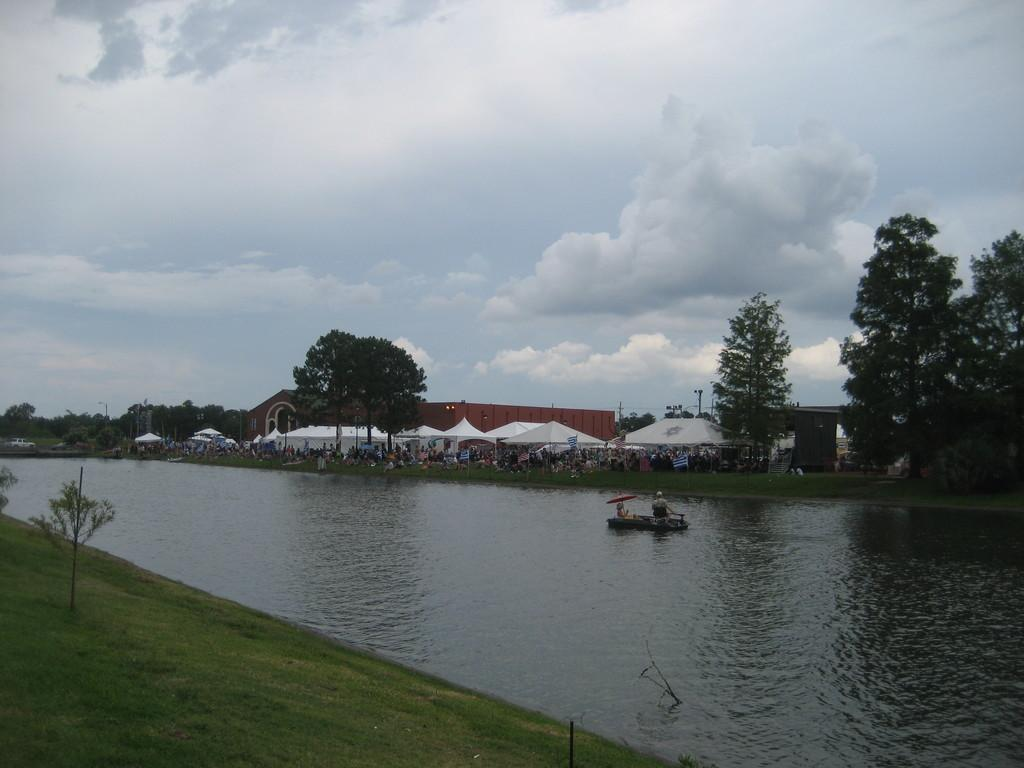What type of natural environment is depicted in the image? The image contains grass, plants, trees, water, and a sky with clouds, suggesting a natural outdoor setting. What type of shelter is present in the image? There is a tent in the image. Are there any people in the image? Yes, there are people in the image. What is the water element in the image used for? The water element in the image is used for a boat, suggesting it might be a body of water for recreational activities. What is visible in the sky in the image? The sky is visible in the image, with clouds present. What month is it in the image? The image does not provide any information about the month or time of year. How does the boat wash the clouds in the image? The boat does not wash the clouds in the image; there is no interaction between the boat and the clouds. 